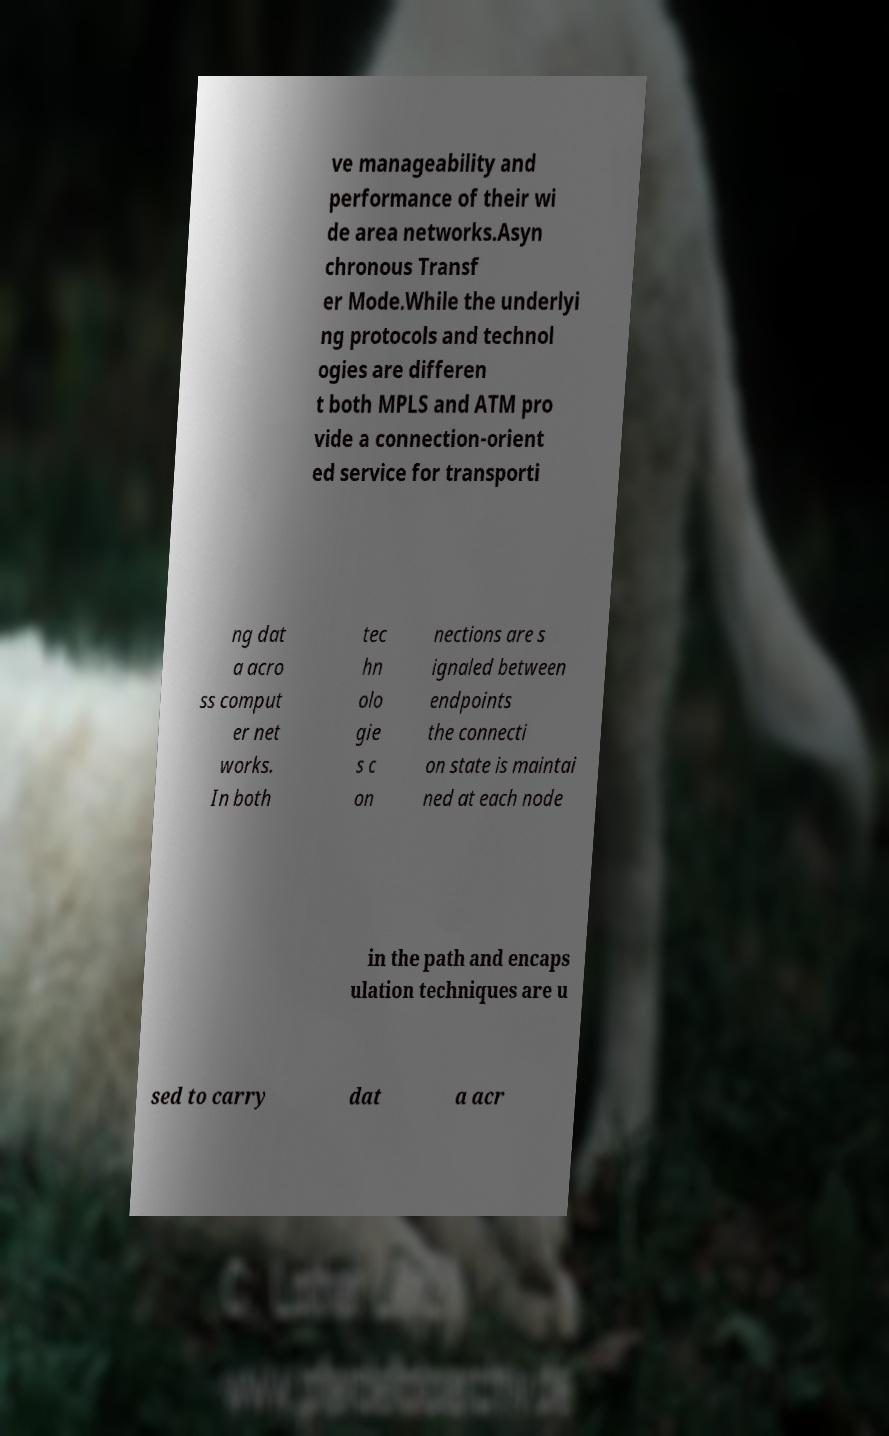Could you assist in decoding the text presented in this image and type it out clearly? ve manageability and performance of their wi de area networks.Asyn chronous Transf er Mode.While the underlyi ng protocols and technol ogies are differen t both MPLS and ATM pro vide a connection-orient ed service for transporti ng dat a acro ss comput er net works. In both tec hn olo gie s c on nections are s ignaled between endpoints the connecti on state is maintai ned at each node in the path and encaps ulation techniques are u sed to carry dat a acr 